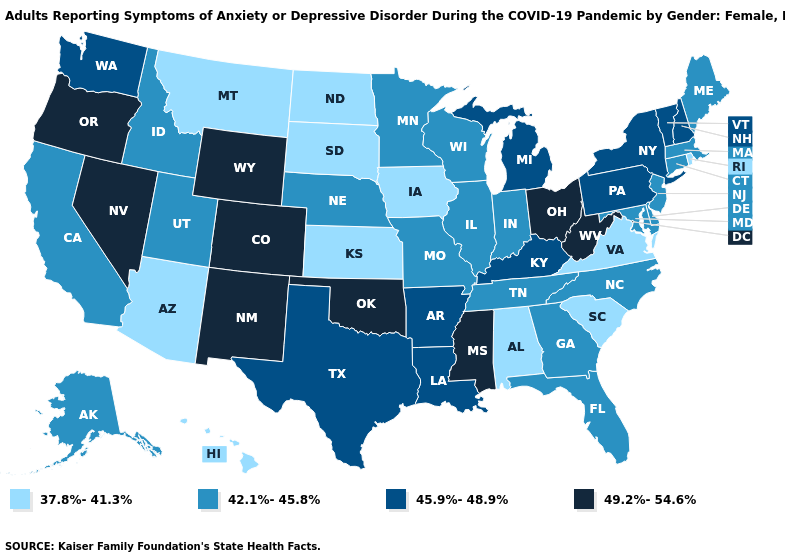What is the value of Indiana?
Answer briefly. 42.1%-45.8%. Does New York have the highest value in the Northeast?
Quick response, please. Yes. What is the value of North Carolina?
Write a very short answer. 42.1%-45.8%. What is the lowest value in states that border Wyoming?
Keep it brief. 37.8%-41.3%. Name the states that have a value in the range 37.8%-41.3%?
Answer briefly. Alabama, Arizona, Hawaii, Iowa, Kansas, Montana, North Dakota, Rhode Island, South Carolina, South Dakota, Virginia. What is the value of Georgia?
Be succinct. 42.1%-45.8%. Does Mississippi have the highest value in the South?
Give a very brief answer. Yes. How many symbols are there in the legend?
Keep it brief. 4. Name the states that have a value in the range 37.8%-41.3%?
Be succinct. Alabama, Arizona, Hawaii, Iowa, Kansas, Montana, North Dakota, Rhode Island, South Carolina, South Dakota, Virginia. What is the value of Washington?
Short answer required. 45.9%-48.9%. What is the value of Vermont?
Be succinct. 45.9%-48.9%. Name the states that have a value in the range 37.8%-41.3%?
Answer briefly. Alabama, Arizona, Hawaii, Iowa, Kansas, Montana, North Dakota, Rhode Island, South Carolina, South Dakota, Virginia. What is the highest value in states that border North Carolina?
Answer briefly. 42.1%-45.8%. What is the value of Arkansas?
Give a very brief answer. 45.9%-48.9%. What is the value of New Jersey?
Concise answer only. 42.1%-45.8%. 